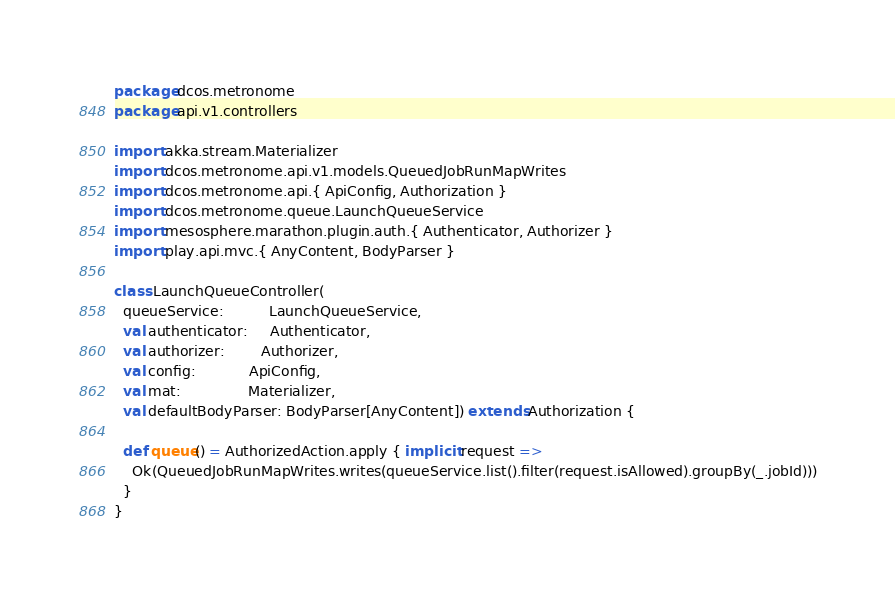Convert code to text. <code><loc_0><loc_0><loc_500><loc_500><_Scala_>package dcos.metronome
package api.v1.controllers

import akka.stream.Materializer
import dcos.metronome.api.v1.models.QueuedJobRunMapWrites
import dcos.metronome.api.{ ApiConfig, Authorization }
import dcos.metronome.queue.LaunchQueueService
import mesosphere.marathon.plugin.auth.{ Authenticator, Authorizer }
import play.api.mvc.{ AnyContent, BodyParser }

class LaunchQueueController(
  queueService:          LaunchQueueService,
  val authenticator:     Authenticator,
  val authorizer:        Authorizer,
  val config:            ApiConfig,
  val mat:               Materializer,
  val defaultBodyParser: BodyParser[AnyContent]) extends Authorization {

  def queue() = AuthorizedAction.apply { implicit request =>
    Ok(QueuedJobRunMapWrites.writes(queueService.list().filter(request.isAllowed).groupBy(_.jobId)))
  }
}
</code> 